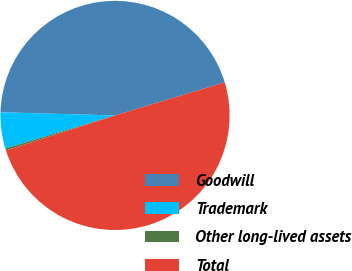Convert chart. <chart><loc_0><loc_0><loc_500><loc_500><pie_chart><fcel>Goodwill<fcel>Trademark<fcel>Other long-lived assets<fcel>Total<nl><fcel>44.9%<fcel>5.1%<fcel>0.28%<fcel>49.72%<nl></chart> 